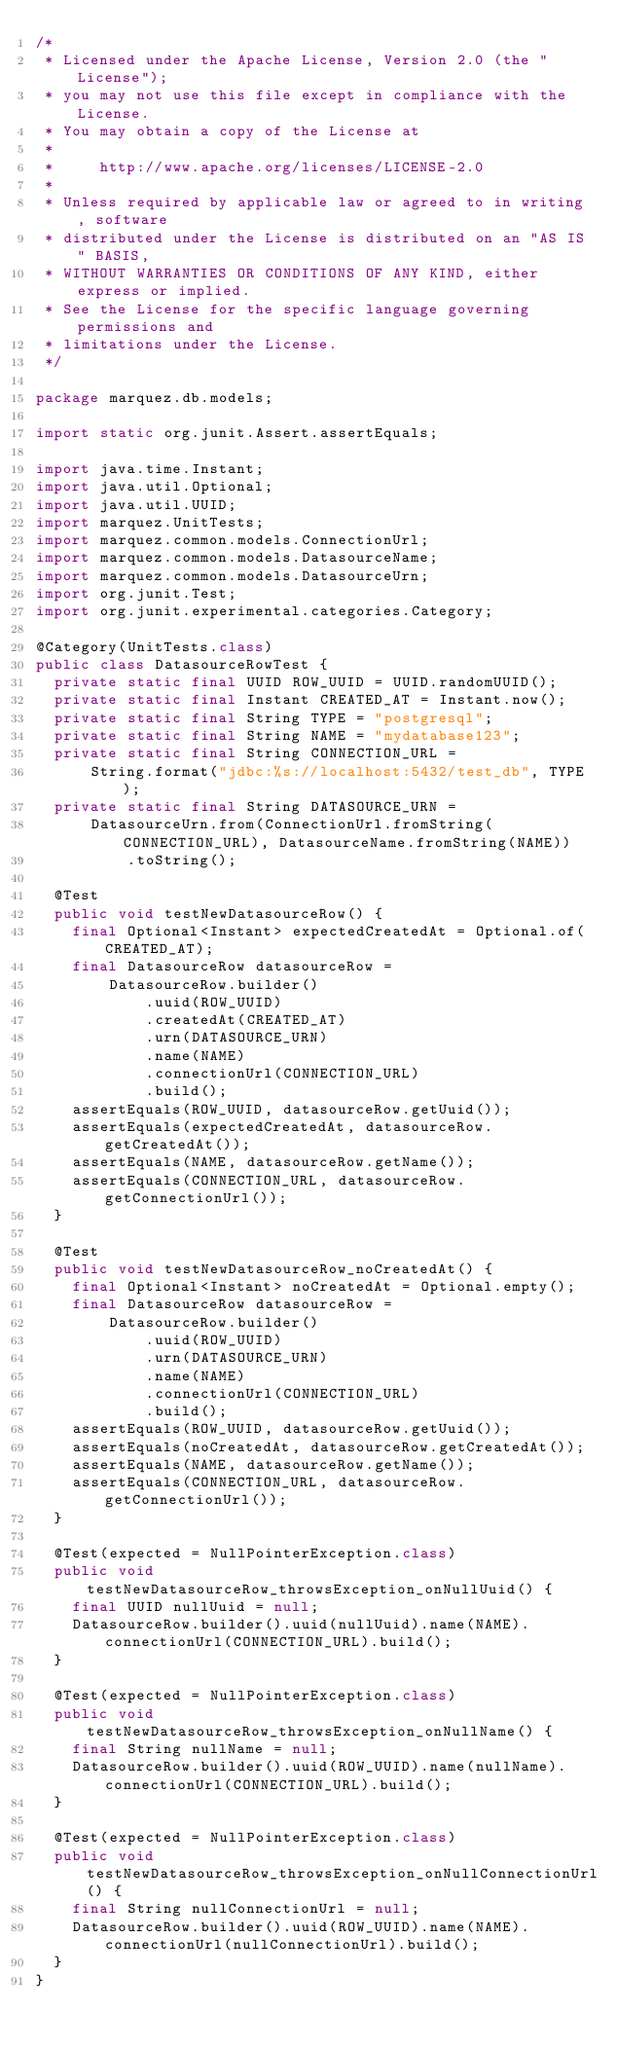<code> <loc_0><loc_0><loc_500><loc_500><_Java_>/*
 * Licensed under the Apache License, Version 2.0 (the "License");
 * you may not use this file except in compliance with the License.
 * You may obtain a copy of the License at
 *
 *     http://www.apache.org/licenses/LICENSE-2.0
 *
 * Unless required by applicable law or agreed to in writing, software
 * distributed under the License is distributed on an "AS IS" BASIS,
 * WITHOUT WARRANTIES OR CONDITIONS OF ANY KIND, either express or implied.
 * See the License for the specific language governing permissions and
 * limitations under the License.
 */

package marquez.db.models;

import static org.junit.Assert.assertEquals;

import java.time.Instant;
import java.util.Optional;
import java.util.UUID;
import marquez.UnitTests;
import marquez.common.models.ConnectionUrl;
import marquez.common.models.DatasourceName;
import marquez.common.models.DatasourceUrn;
import org.junit.Test;
import org.junit.experimental.categories.Category;

@Category(UnitTests.class)
public class DatasourceRowTest {
  private static final UUID ROW_UUID = UUID.randomUUID();
  private static final Instant CREATED_AT = Instant.now();
  private static final String TYPE = "postgresql";
  private static final String NAME = "mydatabase123";
  private static final String CONNECTION_URL =
      String.format("jdbc:%s://localhost:5432/test_db", TYPE);
  private static final String DATASOURCE_URN =
      DatasourceUrn.from(ConnectionUrl.fromString(CONNECTION_URL), DatasourceName.fromString(NAME))
          .toString();

  @Test
  public void testNewDatasourceRow() {
    final Optional<Instant> expectedCreatedAt = Optional.of(CREATED_AT);
    final DatasourceRow datasourceRow =
        DatasourceRow.builder()
            .uuid(ROW_UUID)
            .createdAt(CREATED_AT)
            .urn(DATASOURCE_URN)
            .name(NAME)
            .connectionUrl(CONNECTION_URL)
            .build();
    assertEquals(ROW_UUID, datasourceRow.getUuid());
    assertEquals(expectedCreatedAt, datasourceRow.getCreatedAt());
    assertEquals(NAME, datasourceRow.getName());
    assertEquals(CONNECTION_URL, datasourceRow.getConnectionUrl());
  }

  @Test
  public void testNewDatasourceRow_noCreatedAt() {
    final Optional<Instant> noCreatedAt = Optional.empty();
    final DatasourceRow datasourceRow =
        DatasourceRow.builder()
            .uuid(ROW_UUID)
            .urn(DATASOURCE_URN)
            .name(NAME)
            .connectionUrl(CONNECTION_URL)
            .build();
    assertEquals(ROW_UUID, datasourceRow.getUuid());
    assertEquals(noCreatedAt, datasourceRow.getCreatedAt());
    assertEquals(NAME, datasourceRow.getName());
    assertEquals(CONNECTION_URL, datasourceRow.getConnectionUrl());
  }

  @Test(expected = NullPointerException.class)
  public void testNewDatasourceRow_throwsException_onNullUuid() {
    final UUID nullUuid = null;
    DatasourceRow.builder().uuid(nullUuid).name(NAME).connectionUrl(CONNECTION_URL).build();
  }

  @Test(expected = NullPointerException.class)
  public void testNewDatasourceRow_throwsException_onNullName() {
    final String nullName = null;
    DatasourceRow.builder().uuid(ROW_UUID).name(nullName).connectionUrl(CONNECTION_URL).build();
  }

  @Test(expected = NullPointerException.class)
  public void testNewDatasourceRow_throwsException_onNullConnectionUrl() {
    final String nullConnectionUrl = null;
    DatasourceRow.builder().uuid(ROW_UUID).name(NAME).connectionUrl(nullConnectionUrl).build();
  }
}
</code> 